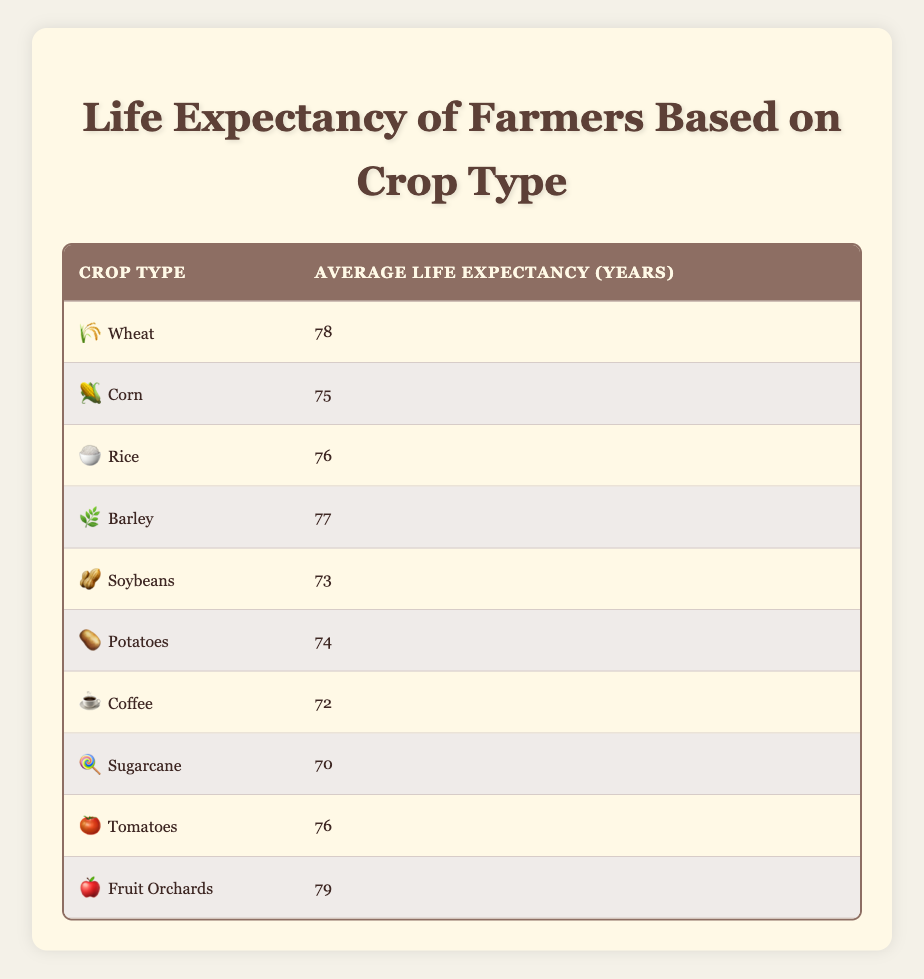What is the average life expectancy for farmers cultivating Barley? The table states that the average life expectancy for farmers cultivating Barley is listed as 77 years.
Answer: 77 Which crop type has the highest average life expectancy? According to the table, Fruit Orchards have the highest average life expectancy at 79 years.
Answer: 79 Is the average life expectancy for Coffee farmers greater than that of Soybean farmers? The table shows that Coffee farmers have an average life expectancy of 72 years, while Soybean farmers have an average life expectancy of 73 years. Therefore, the statement is false.
Answer: No What is the difference in average life expectancy between farmers of Wheat and Sugarcane? Wheat farmers have an average life expectancy of 78 years while Sugarcane farmers have 70 years. The difference is calculated as 78 - 70 = 8 years.
Answer: 8 How many crop types listed have an average life expectancy below 75 years? The table lists six crop types with average life expectancies below 75 years: Soybeans (73), Coffee (72), and Sugarcane (70). Therefore, the count is 3 crop types.
Answer: 3 What is the average life expectancy for farmers cultivating Corn and Rice combined? The average life expectancy for Corn farmers is 75 years and for Rice farmers, it is 76 years. To find the average, we sum these values (75 + 76 = 151) and divide by 2, which gives us an average of 75.5 years.
Answer: 75.5 True or False: Farmers who cultivate Potatoes live longer, on average, than those who cultivate Coffee. From the table, Potatoes have an average life expectancy of 74 years, while Coffee has 72 years. Since 74 is greater than 72, the statement is true.
Answer: True Which crop types have an average life expectancy above 76 years? Examining the table, we see that the crop types with average life expectancies above 76 years are Fruit Orchards (79 years) and Wheat (78 years). Therefore, there are two such crop types.
Answer: 2 What is the average life expectancy of all the crops listed in the table? To compute the average, we first sum all the average life expectancies of the crop types: 78 + 75 + 76 + 77 + 73 + 74 + 72 + 70 + 76 + 79 = 780. Then, we divide this sum by the number of crop types, which is 10: 780 / 10 = 78 years.
Answer: 78 